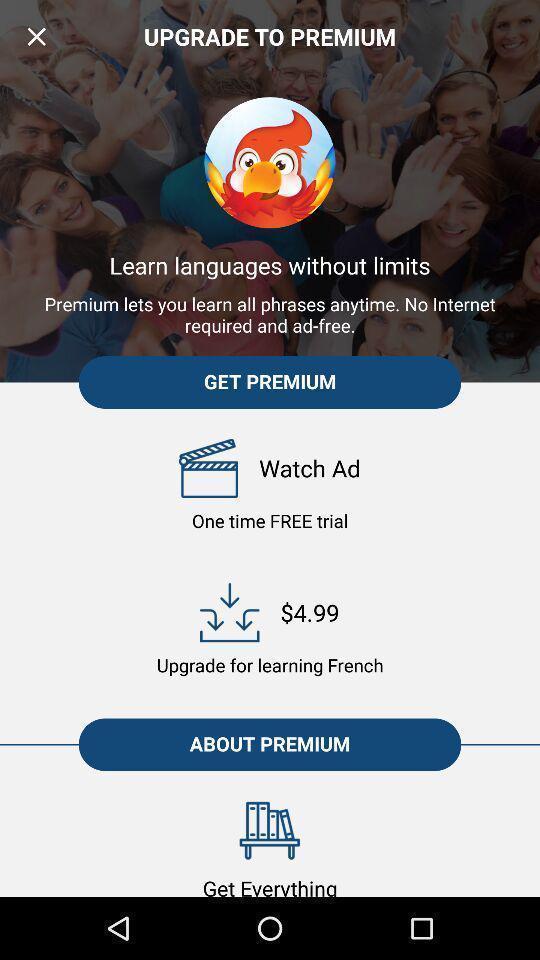Explain what's happening in this screen capture. Screen displaying screen page of a language learning app. 